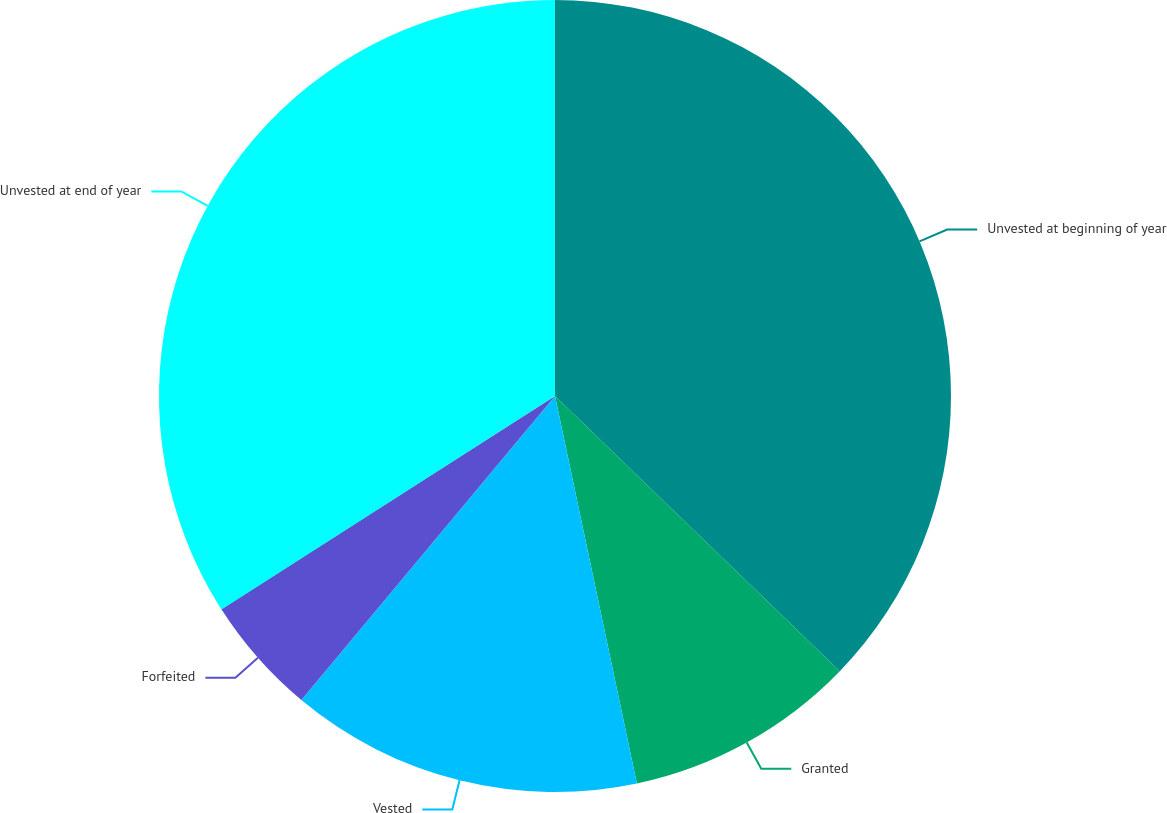Convert chart to OTSL. <chart><loc_0><loc_0><loc_500><loc_500><pie_chart><fcel>Unvested at beginning of year<fcel>Granted<fcel>Vested<fcel>Forfeited<fcel>Unvested at end of year<nl><fcel>37.23%<fcel>9.46%<fcel>14.38%<fcel>4.88%<fcel>34.06%<nl></chart> 